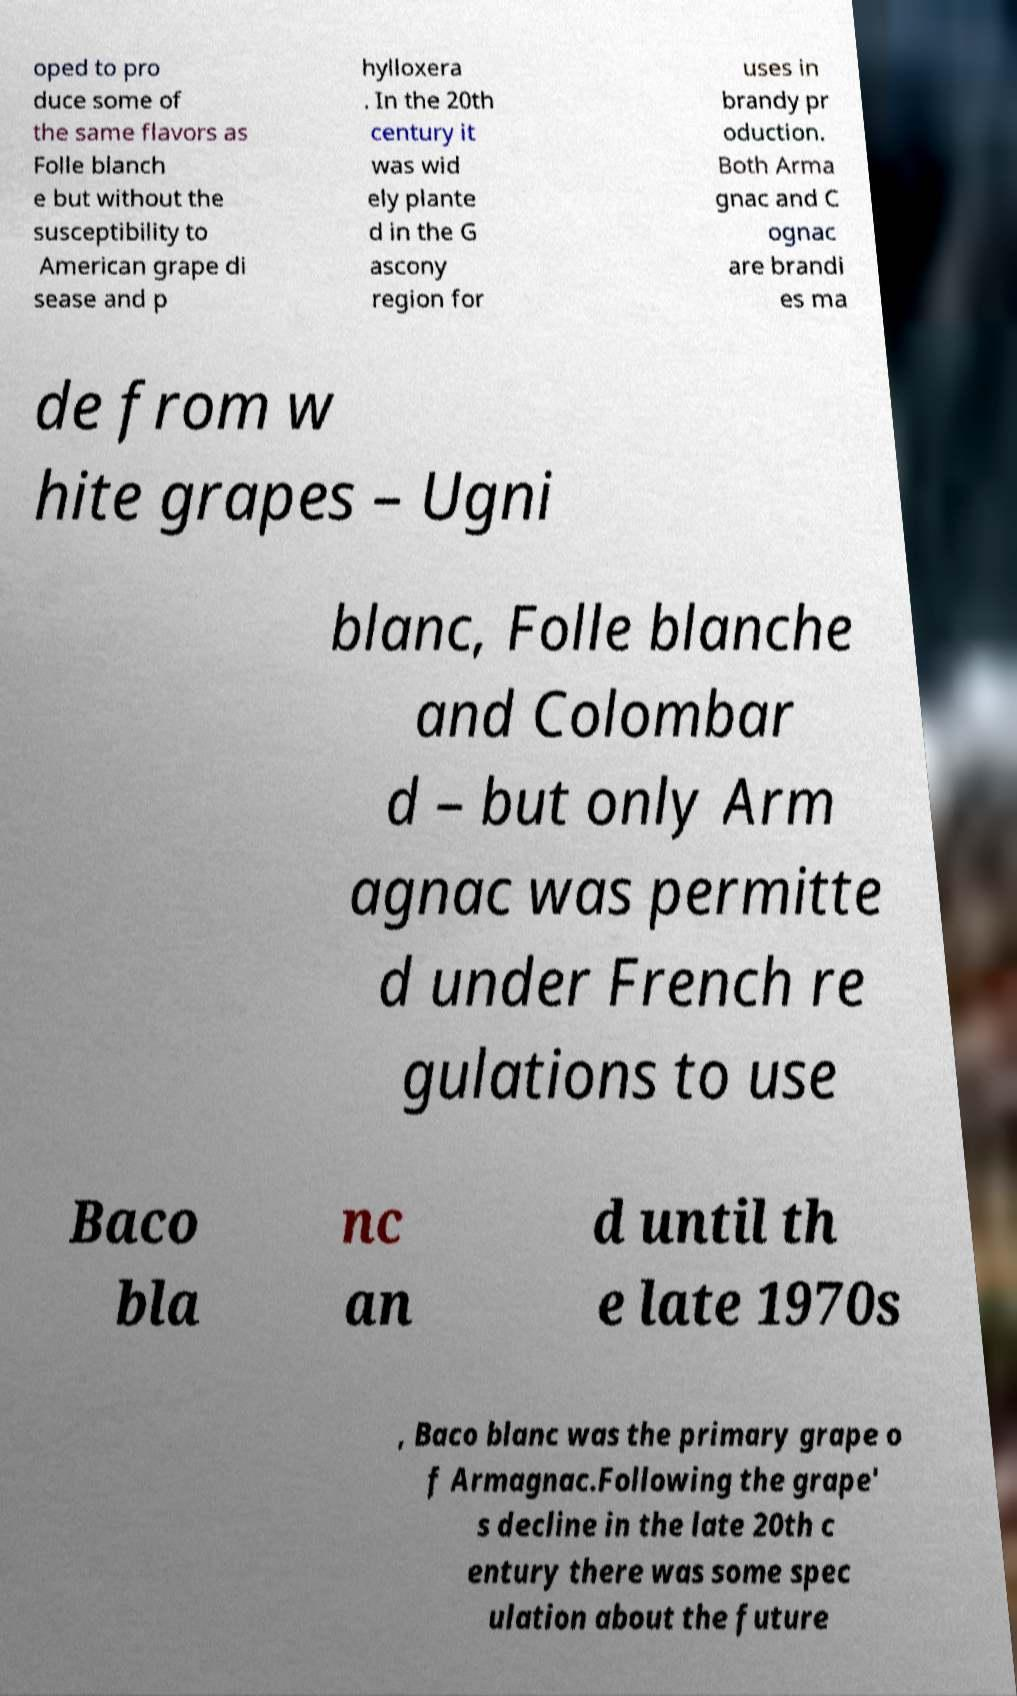What messages or text are displayed in this image? I need them in a readable, typed format. oped to pro duce some of the same flavors as Folle blanch e but without the susceptibility to American grape di sease and p hylloxera . In the 20th century it was wid ely plante d in the G ascony region for uses in brandy pr oduction. Both Arma gnac and C ognac are brandi es ma de from w hite grapes – Ugni blanc, Folle blanche and Colombar d – but only Arm agnac was permitte d under French re gulations to use Baco bla nc an d until th e late 1970s , Baco blanc was the primary grape o f Armagnac.Following the grape' s decline in the late 20th c entury there was some spec ulation about the future 